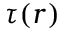Convert formula to latex. <formula><loc_0><loc_0><loc_500><loc_500>\tau ( r )</formula> 